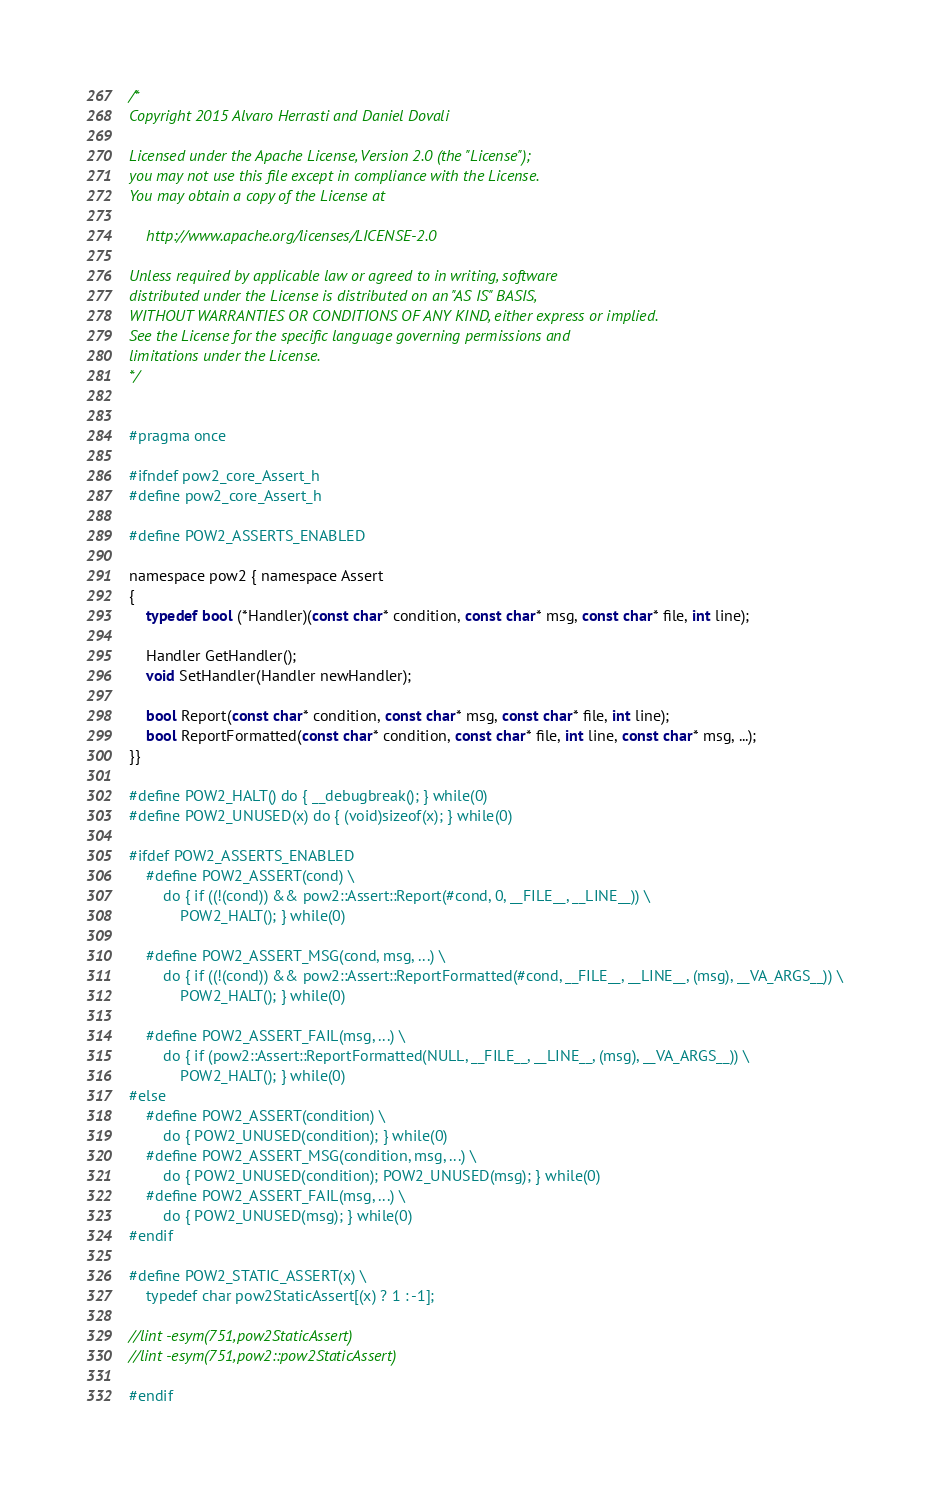Convert code to text. <code><loc_0><loc_0><loc_500><loc_500><_C_>/* 
Copyright 2015 Alvaro Herrasti and Daniel Dovali

Licensed under the Apache License, Version 2.0 (the "License");
you may not use this file except in compliance with the License.
You may obtain a copy of the License at

    http://www.apache.org/licenses/LICENSE-2.0

Unless required by applicable law or agreed to in writing, software
distributed under the License is distributed on an "AS IS" BASIS,
WITHOUT WARRANTIES OR CONDITIONS OF ANY KIND, either express or implied.
See the License for the specific language governing permissions and
limitations under the License.
*/


#pragma once

#ifndef pow2_core_Assert_h
#define pow2_core_Assert_h

#define POW2_ASSERTS_ENABLED

namespace pow2 { namespace Assert
{
	typedef bool (*Handler)(const char* condition, const char* msg, const char* file, int line);

	Handler GetHandler();
	void SetHandler(Handler newHandler);
	
	bool Report(const char* condition, const char* msg, const char* file, int line);
	bool ReportFormatted(const char* condition, const char* file, int line, const char* msg, ...);
}}

#define POW2_HALT() do { __debugbreak(); } while(0)
#define POW2_UNUSED(x) do { (void)sizeof(x); } while(0)

#ifdef POW2_ASSERTS_ENABLED
	#define POW2_ASSERT(cond) \
		do { if ((!(cond)) && pow2::Assert::Report(#cond, 0, __FILE__, __LINE__)) \
			POW2_HALT(); } while(0)

	#define POW2_ASSERT_MSG(cond, msg, ...) \
		do { if ((!(cond)) && pow2::Assert::ReportFormatted(#cond, __FILE__, __LINE__, (msg), __VA_ARGS__)) \
			POW2_HALT(); } while(0)

	#define POW2_ASSERT_FAIL(msg, ...) \
		do { if (pow2::Assert::ReportFormatted(NULL, __FILE__, __LINE__, (msg), __VA_ARGS__)) \
			POW2_HALT(); } while(0)
#else
	#define POW2_ASSERT(condition) \
		do { POW2_UNUSED(condition); } while(0)
	#define POW2_ASSERT_MSG(condition, msg, ...) \
		do { POW2_UNUSED(condition); POW2_UNUSED(msg); } while(0)
	#define POW2_ASSERT_FAIL(msg, ...) \
		do { POW2_UNUSED(msg); } while(0)
#endif

#define POW2_STATIC_ASSERT(x) \
	typedef char pow2StaticAssert[(x) ? 1 : -1];

//lint -esym(751,pow2StaticAssert)
//lint -esym(751,pow2::pow2StaticAssert)

#endif
</code> 